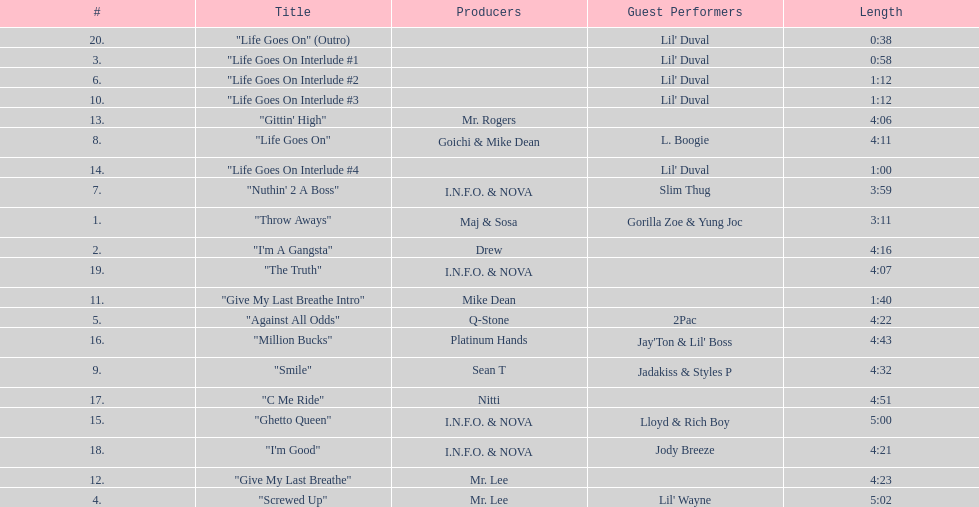What is the longest track on the album? "Screwed Up". 